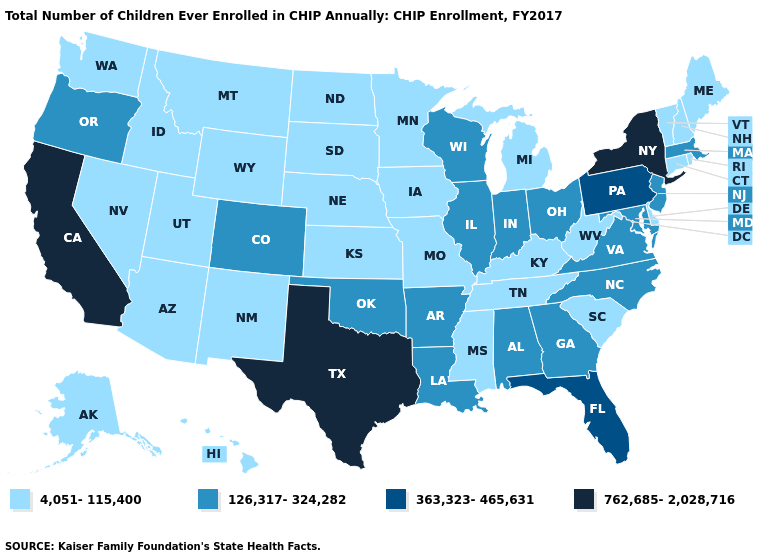What is the value of Washington?
Be succinct. 4,051-115,400. Does Virginia have the highest value in the South?
Keep it brief. No. What is the value of Louisiana?
Keep it brief. 126,317-324,282. Name the states that have a value in the range 762,685-2,028,716?
Concise answer only. California, New York, Texas. Is the legend a continuous bar?
Concise answer only. No. Does Arkansas have the lowest value in the USA?
Be succinct. No. What is the value of Pennsylvania?
Give a very brief answer. 363,323-465,631. Name the states that have a value in the range 126,317-324,282?
Short answer required. Alabama, Arkansas, Colorado, Georgia, Illinois, Indiana, Louisiana, Maryland, Massachusetts, New Jersey, North Carolina, Ohio, Oklahoma, Oregon, Virginia, Wisconsin. Name the states that have a value in the range 762,685-2,028,716?
Keep it brief. California, New York, Texas. Which states hav the highest value in the West?
Give a very brief answer. California. Does New Mexico have the lowest value in the USA?
Answer briefly. Yes. What is the highest value in states that border Texas?
Keep it brief. 126,317-324,282. What is the value of Mississippi?
Write a very short answer. 4,051-115,400. Among the states that border California , does Nevada have the lowest value?
Short answer required. Yes. Name the states that have a value in the range 126,317-324,282?
Give a very brief answer. Alabama, Arkansas, Colorado, Georgia, Illinois, Indiana, Louisiana, Maryland, Massachusetts, New Jersey, North Carolina, Ohio, Oklahoma, Oregon, Virginia, Wisconsin. 